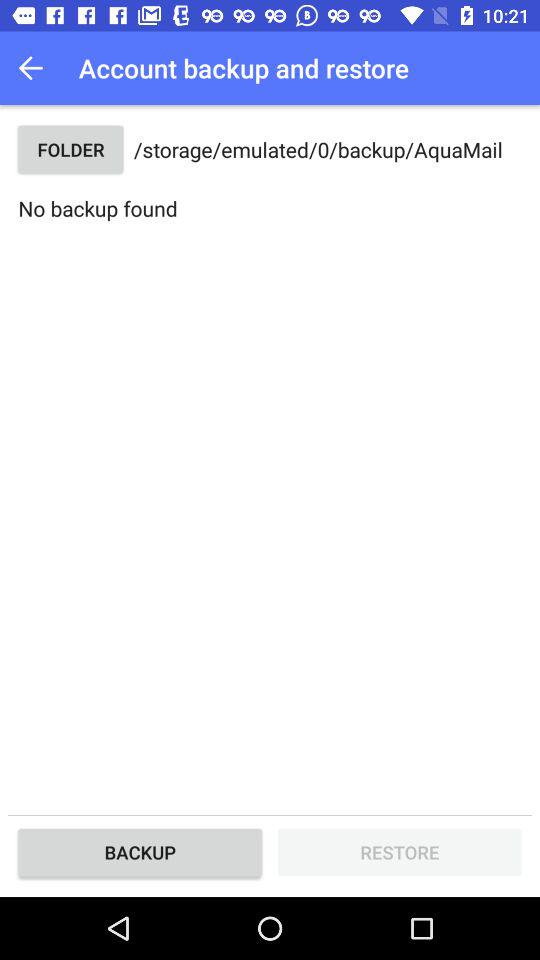How many backup files are there?
Answer the question using a single word or phrase. 0 